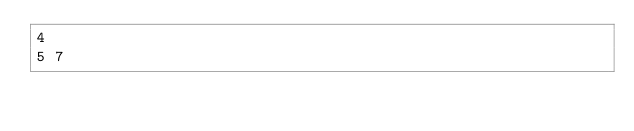Convert code to text. <code><loc_0><loc_0><loc_500><loc_500><_Python_>4
5 7</code> 